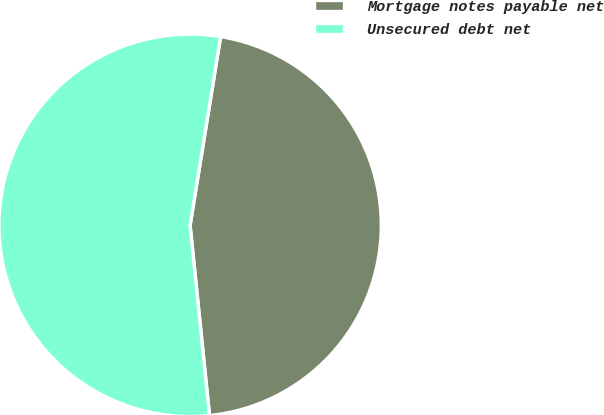Convert chart to OTSL. <chart><loc_0><loc_0><loc_500><loc_500><pie_chart><fcel>Mortgage notes payable net<fcel>Unsecured debt net<nl><fcel>45.83%<fcel>54.17%<nl></chart> 